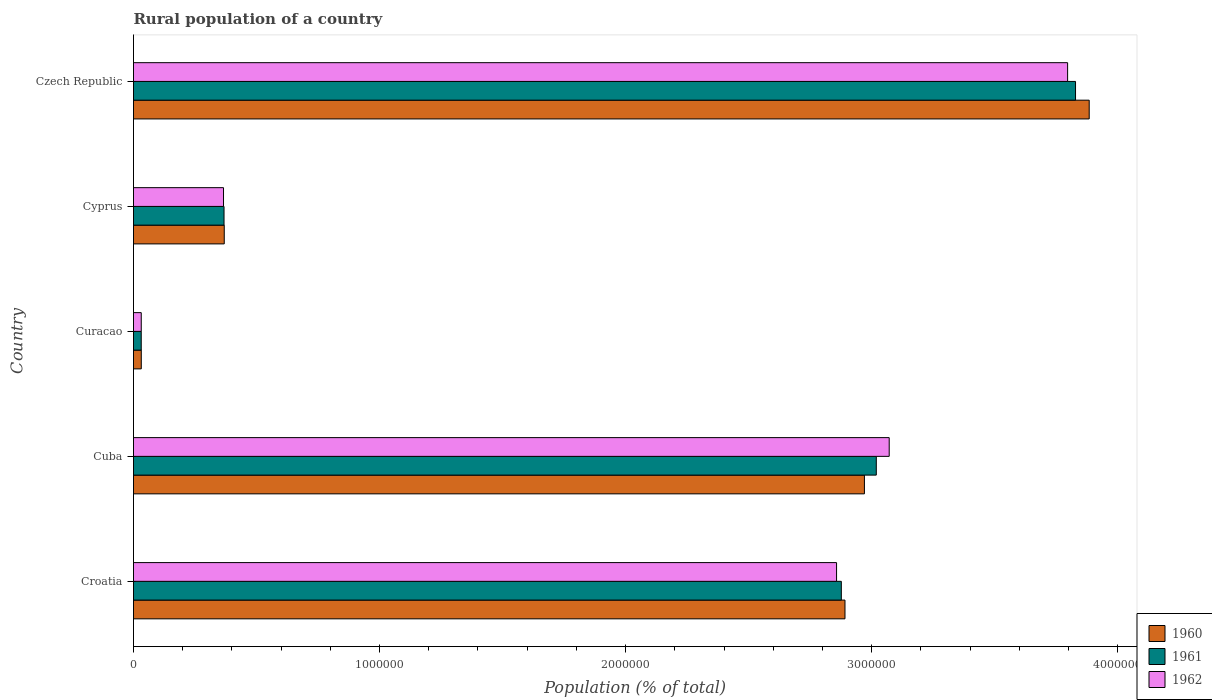How many different coloured bars are there?
Offer a terse response. 3. How many groups of bars are there?
Offer a terse response. 5. How many bars are there on the 3rd tick from the bottom?
Your response must be concise. 3. What is the label of the 1st group of bars from the top?
Give a very brief answer. Czech Republic. In how many cases, is the number of bars for a given country not equal to the number of legend labels?
Provide a succinct answer. 0. What is the rural population in 1962 in Czech Republic?
Your answer should be very brief. 3.80e+06. Across all countries, what is the maximum rural population in 1961?
Your answer should be very brief. 3.83e+06. Across all countries, what is the minimum rural population in 1960?
Your answer should be compact. 3.16e+04. In which country was the rural population in 1960 maximum?
Offer a terse response. Czech Republic. In which country was the rural population in 1962 minimum?
Offer a very short reply. Curacao. What is the total rural population in 1961 in the graph?
Your response must be concise. 1.01e+07. What is the difference between the rural population in 1962 in Cuba and that in Cyprus?
Your answer should be compact. 2.71e+06. What is the difference between the rural population in 1960 in Croatia and the rural population in 1961 in Cyprus?
Provide a short and direct response. 2.52e+06. What is the average rural population in 1961 per country?
Give a very brief answer. 2.02e+06. What is the difference between the rural population in 1961 and rural population in 1962 in Cyprus?
Provide a short and direct response. 2055. In how many countries, is the rural population in 1960 greater than 3200000 %?
Provide a succinct answer. 1. What is the ratio of the rural population in 1962 in Cuba to that in Curacao?
Keep it short and to the point. 97.58. Is the rural population in 1960 in Curacao less than that in Cyprus?
Your answer should be very brief. Yes. What is the difference between the highest and the second highest rural population in 1962?
Offer a very short reply. 7.25e+05. What is the difference between the highest and the lowest rural population in 1962?
Your answer should be very brief. 3.76e+06. In how many countries, is the rural population in 1962 greater than the average rural population in 1962 taken over all countries?
Your answer should be compact. 3. What does the 1st bar from the top in Cyprus represents?
Your answer should be compact. 1962. Is it the case that in every country, the sum of the rural population in 1962 and rural population in 1961 is greater than the rural population in 1960?
Your answer should be compact. Yes. How many bars are there?
Offer a very short reply. 15. Are all the bars in the graph horizontal?
Offer a terse response. Yes. How many countries are there in the graph?
Ensure brevity in your answer.  5. Does the graph contain grids?
Offer a very short reply. No. Where does the legend appear in the graph?
Keep it short and to the point. Bottom right. How many legend labels are there?
Your answer should be compact. 3. What is the title of the graph?
Ensure brevity in your answer.  Rural population of a country. Does "1969" appear as one of the legend labels in the graph?
Ensure brevity in your answer.  No. What is the label or title of the X-axis?
Your answer should be compact. Population (% of total). What is the label or title of the Y-axis?
Offer a very short reply. Country. What is the Population (% of total) of 1960 in Croatia?
Your response must be concise. 2.89e+06. What is the Population (% of total) of 1961 in Croatia?
Ensure brevity in your answer.  2.88e+06. What is the Population (% of total) of 1962 in Croatia?
Your answer should be compact. 2.86e+06. What is the Population (% of total) of 1960 in Cuba?
Offer a terse response. 2.97e+06. What is the Population (% of total) of 1961 in Cuba?
Give a very brief answer. 3.02e+06. What is the Population (% of total) in 1962 in Cuba?
Ensure brevity in your answer.  3.07e+06. What is the Population (% of total) in 1960 in Curacao?
Your answer should be very brief. 3.16e+04. What is the Population (% of total) in 1961 in Curacao?
Offer a very short reply. 3.14e+04. What is the Population (% of total) of 1962 in Curacao?
Provide a succinct answer. 3.15e+04. What is the Population (% of total) in 1960 in Cyprus?
Provide a succinct answer. 3.69e+05. What is the Population (% of total) of 1961 in Cyprus?
Provide a short and direct response. 3.68e+05. What is the Population (% of total) of 1962 in Cyprus?
Your answer should be very brief. 3.66e+05. What is the Population (% of total) of 1960 in Czech Republic?
Keep it short and to the point. 3.88e+06. What is the Population (% of total) of 1961 in Czech Republic?
Ensure brevity in your answer.  3.83e+06. What is the Population (% of total) in 1962 in Czech Republic?
Your answer should be compact. 3.80e+06. Across all countries, what is the maximum Population (% of total) of 1960?
Offer a very short reply. 3.88e+06. Across all countries, what is the maximum Population (% of total) of 1961?
Ensure brevity in your answer.  3.83e+06. Across all countries, what is the maximum Population (% of total) of 1962?
Provide a succinct answer. 3.80e+06. Across all countries, what is the minimum Population (% of total) of 1960?
Make the answer very short. 3.16e+04. Across all countries, what is the minimum Population (% of total) of 1961?
Provide a short and direct response. 3.14e+04. Across all countries, what is the minimum Population (% of total) in 1962?
Ensure brevity in your answer.  3.15e+04. What is the total Population (% of total) in 1960 in the graph?
Provide a short and direct response. 1.01e+07. What is the total Population (% of total) of 1961 in the graph?
Provide a succinct answer. 1.01e+07. What is the total Population (% of total) of 1962 in the graph?
Offer a terse response. 1.01e+07. What is the difference between the Population (% of total) of 1960 in Croatia and that in Cuba?
Offer a very short reply. -7.90e+04. What is the difference between the Population (% of total) of 1961 in Croatia and that in Cuba?
Offer a terse response. -1.42e+05. What is the difference between the Population (% of total) of 1962 in Croatia and that in Cuba?
Provide a succinct answer. -2.14e+05. What is the difference between the Population (% of total) of 1960 in Croatia and that in Curacao?
Your response must be concise. 2.86e+06. What is the difference between the Population (% of total) in 1961 in Croatia and that in Curacao?
Provide a short and direct response. 2.85e+06. What is the difference between the Population (% of total) of 1962 in Croatia and that in Curacao?
Give a very brief answer. 2.83e+06. What is the difference between the Population (% of total) in 1960 in Croatia and that in Cyprus?
Offer a very short reply. 2.52e+06. What is the difference between the Population (% of total) of 1961 in Croatia and that in Cyprus?
Give a very brief answer. 2.51e+06. What is the difference between the Population (% of total) in 1962 in Croatia and that in Cyprus?
Offer a very short reply. 2.49e+06. What is the difference between the Population (% of total) of 1960 in Croatia and that in Czech Republic?
Offer a terse response. -9.93e+05. What is the difference between the Population (% of total) in 1961 in Croatia and that in Czech Republic?
Your answer should be very brief. -9.52e+05. What is the difference between the Population (% of total) of 1962 in Croatia and that in Czech Republic?
Keep it short and to the point. -9.39e+05. What is the difference between the Population (% of total) in 1960 in Cuba and that in Curacao?
Your answer should be very brief. 2.94e+06. What is the difference between the Population (% of total) of 1961 in Cuba and that in Curacao?
Offer a very short reply. 2.99e+06. What is the difference between the Population (% of total) of 1962 in Cuba and that in Curacao?
Your answer should be compact. 3.04e+06. What is the difference between the Population (% of total) of 1960 in Cuba and that in Cyprus?
Give a very brief answer. 2.60e+06. What is the difference between the Population (% of total) of 1961 in Cuba and that in Cyprus?
Ensure brevity in your answer.  2.65e+06. What is the difference between the Population (% of total) of 1962 in Cuba and that in Cyprus?
Your response must be concise. 2.71e+06. What is the difference between the Population (% of total) in 1960 in Cuba and that in Czech Republic?
Give a very brief answer. -9.14e+05. What is the difference between the Population (% of total) of 1961 in Cuba and that in Czech Republic?
Your response must be concise. -8.10e+05. What is the difference between the Population (% of total) in 1962 in Cuba and that in Czech Republic?
Ensure brevity in your answer.  -7.25e+05. What is the difference between the Population (% of total) in 1960 in Curacao and that in Cyprus?
Your answer should be compact. -3.37e+05. What is the difference between the Population (% of total) of 1961 in Curacao and that in Cyprus?
Your response must be concise. -3.36e+05. What is the difference between the Population (% of total) in 1962 in Curacao and that in Cyprus?
Provide a short and direct response. -3.34e+05. What is the difference between the Population (% of total) in 1960 in Curacao and that in Czech Republic?
Provide a succinct answer. -3.85e+06. What is the difference between the Population (% of total) in 1961 in Curacao and that in Czech Republic?
Ensure brevity in your answer.  -3.80e+06. What is the difference between the Population (% of total) of 1962 in Curacao and that in Czech Republic?
Offer a very short reply. -3.76e+06. What is the difference between the Population (% of total) in 1960 in Cyprus and that in Czech Republic?
Your answer should be compact. -3.52e+06. What is the difference between the Population (% of total) of 1961 in Cyprus and that in Czech Republic?
Your response must be concise. -3.46e+06. What is the difference between the Population (% of total) in 1962 in Cyprus and that in Czech Republic?
Give a very brief answer. -3.43e+06. What is the difference between the Population (% of total) in 1960 in Croatia and the Population (% of total) in 1961 in Cuba?
Ensure brevity in your answer.  -1.27e+05. What is the difference between the Population (% of total) of 1960 in Croatia and the Population (% of total) of 1962 in Cuba?
Keep it short and to the point. -1.80e+05. What is the difference between the Population (% of total) of 1961 in Croatia and the Population (% of total) of 1962 in Cuba?
Make the answer very short. -1.95e+05. What is the difference between the Population (% of total) in 1960 in Croatia and the Population (% of total) in 1961 in Curacao?
Provide a short and direct response. 2.86e+06. What is the difference between the Population (% of total) in 1960 in Croatia and the Population (% of total) in 1962 in Curacao?
Make the answer very short. 2.86e+06. What is the difference between the Population (% of total) in 1961 in Croatia and the Population (% of total) in 1962 in Curacao?
Offer a very short reply. 2.85e+06. What is the difference between the Population (% of total) of 1960 in Croatia and the Population (% of total) of 1961 in Cyprus?
Provide a succinct answer. 2.52e+06. What is the difference between the Population (% of total) in 1960 in Croatia and the Population (% of total) in 1962 in Cyprus?
Offer a terse response. 2.53e+06. What is the difference between the Population (% of total) in 1961 in Croatia and the Population (% of total) in 1962 in Cyprus?
Give a very brief answer. 2.51e+06. What is the difference between the Population (% of total) in 1960 in Croatia and the Population (% of total) in 1961 in Czech Republic?
Ensure brevity in your answer.  -9.37e+05. What is the difference between the Population (% of total) of 1960 in Croatia and the Population (% of total) of 1962 in Czech Republic?
Keep it short and to the point. -9.05e+05. What is the difference between the Population (% of total) in 1961 in Croatia and the Population (% of total) in 1962 in Czech Republic?
Keep it short and to the point. -9.20e+05. What is the difference between the Population (% of total) in 1960 in Cuba and the Population (% of total) in 1961 in Curacao?
Provide a succinct answer. 2.94e+06. What is the difference between the Population (% of total) in 1960 in Cuba and the Population (% of total) in 1962 in Curacao?
Keep it short and to the point. 2.94e+06. What is the difference between the Population (% of total) in 1961 in Cuba and the Population (% of total) in 1962 in Curacao?
Make the answer very short. 2.99e+06. What is the difference between the Population (% of total) in 1960 in Cuba and the Population (% of total) in 1961 in Cyprus?
Ensure brevity in your answer.  2.60e+06. What is the difference between the Population (% of total) in 1960 in Cuba and the Population (% of total) in 1962 in Cyprus?
Provide a short and direct response. 2.60e+06. What is the difference between the Population (% of total) in 1961 in Cuba and the Population (% of total) in 1962 in Cyprus?
Offer a terse response. 2.65e+06. What is the difference between the Population (% of total) in 1960 in Cuba and the Population (% of total) in 1961 in Czech Republic?
Provide a succinct answer. -8.58e+05. What is the difference between the Population (% of total) in 1960 in Cuba and the Population (% of total) in 1962 in Czech Republic?
Your answer should be compact. -8.26e+05. What is the difference between the Population (% of total) of 1961 in Cuba and the Population (% of total) of 1962 in Czech Republic?
Ensure brevity in your answer.  -7.78e+05. What is the difference between the Population (% of total) of 1960 in Curacao and the Population (% of total) of 1961 in Cyprus?
Ensure brevity in your answer.  -3.36e+05. What is the difference between the Population (% of total) in 1960 in Curacao and the Population (% of total) in 1962 in Cyprus?
Provide a short and direct response. -3.34e+05. What is the difference between the Population (% of total) in 1961 in Curacao and the Population (% of total) in 1962 in Cyprus?
Make the answer very short. -3.34e+05. What is the difference between the Population (% of total) in 1960 in Curacao and the Population (% of total) in 1961 in Czech Republic?
Ensure brevity in your answer.  -3.80e+06. What is the difference between the Population (% of total) of 1960 in Curacao and the Population (% of total) of 1962 in Czech Republic?
Provide a succinct answer. -3.76e+06. What is the difference between the Population (% of total) of 1961 in Curacao and the Population (% of total) of 1962 in Czech Republic?
Offer a very short reply. -3.77e+06. What is the difference between the Population (% of total) in 1960 in Cyprus and the Population (% of total) in 1961 in Czech Republic?
Provide a succinct answer. -3.46e+06. What is the difference between the Population (% of total) of 1960 in Cyprus and the Population (% of total) of 1962 in Czech Republic?
Give a very brief answer. -3.43e+06. What is the difference between the Population (% of total) of 1961 in Cyprus and the Population (% of total) of 1962 in Czech Republic?
Provide a succinct answer. -3.43e+06. What is the average Population (% of total) in 1960 per country?
Provide a succinct answer. 2.03e+06. What is the average Population (% of total) of 1961 per country?
Provide a short and direct response. 2.02e+06. What is the average Population (% of total) of 1962 per country?
Ensure brevity in your answer.  2.02e+06. What is the difference between the Population (% of total) of 1960 and Population (% of total) of 1961 in Croatia?
Give a very brief answer. 1.48e+04. What is the difference between the Population (% of total) of 1960 and Population (% of total) of 1962 in Croatia?
Offer a terse response. 3.42e+04. What is the difference between the Population (% of total) of 1961 and Population (% of total) of 1962 in Croatia?
Keep it short and to the point. 1.94e+04. What is the difference between the Population (% of total) of 1960 and Population (% of total) of 1961 in Cuba?
Offer a very short reply. -4.82e+04. What is the difference between the Population (% of total) in 1960 and Population (% of total) in 1962 in Cuba?
Keep it short and to the point. -1.01e+05. What is the difference between the Population (% of total) in 1961 and Population (% of total) in 1962 in Cuba?
Your answer should be compact. -5.25e+04. What is the difference between the Population (% of total) of 1960 and Population (% of total) of 1961 in Curacao?
Your response must be concise. 165. What is the difference between the Population (% of total) in 1960 and Population (% of total) in 1962 in Curacao?
Your answer should be compact. 94. What is the difference between the Population (% of total) of 1961 and Population (% of total) of 1962 in Curacao?
Ensure brevity in your answer.  -71. What is the difference between the Population (% of total) in 1960 and Population (% of total) in 1961 in Cyprus?
Your response must be concise. 922. What is the difference between the Population (% of total) of 1960 and Population (% of total) of 1962 in Cyprus?
Give a very brief answer. 2977. What is the difference between the Population (% of total) in 1961 and Population (% of total) in 1962 in Cyprus?
Make the answer very short. 2055. What is the difference between the Population (% of total) in 1960 and Population (% of total) in 1961 in Czech Republic?
Offer a terse response. 5.56e+04. What is the difference between the Population (% of total) of 1960 and Population (% of total) of 1962 in Czech Republic?
Offer a very short reply. 8.78e+04. What is the difference between the Population (% of total) of 1961 and Population (% of total) of 1962 in Czech Republic?
Your answer should be compact. 3.22e+04. What is the ratio of the Population (% of total) of 1960 in Croatia to that in Cuba?
Your answer should be compact. 0.97. What is the ratio of the Population (% of total) of 1961 in Croatia to that in Cuba?
Give a very brief answer. 0.95. What is the ratio of the Population (% of total) in 1962 in Croatia to that in Cuba?
Offer a terse response. 0.93. What is the ratio of the Population (% of total) in 1960 in Croatia to that in Curacao?
Ensure brevity in your answer.  91.6. What is the ratio of the Population (% of total) in 1961 in Croatia to that in Curacao?
Ensure brevity in your answer.  91.61. What is the ratio of the Population (% of total) in 1962 in Croatia to that in Curacao?
Your answer should be very brief. 90.79. What is the ratio of the Population (% of total) in 1960 in Croatia to that in Cyprus?
Your response must be concise. 7.84. What is the ratio of the Population (% of total) in 1961 in Croatia to that in Cyprus?
Give a very brief answer. 7.82. What is the ratio of the Population (% of total) in 1962 in Croatia to that in Cyprus?
Ensure brevity in your answer.  7.81. What is the ratio of the Population (% of total) in 1960 in Croatia to that in Czech Republic?
Offer a very short reply. 0.74. What is the ratio of the Population (% of total) of 1961 in Croatia to that in Czech Republic?
Your answer should be compact. 0.75. What is the ratio of the Population (% of total) in 1962 in Croatia to that in Czech Republic?
Ensure brevity in your answer.  0.75. What is the ratio of the Population (% of total) in 1960 in Cuba to that in Curacao?
Make the answer very short. 94.1. What is the ratio of the Population (% of total) of 1961 in Cuba to that in Curacao?
Provide a short and direct response. 96.13. What is the ratio of the Population (% of total) of 1962 in Cuba to that in Curacao?
Make the answer very short. 97.58. What is the ratio of the Population (% of total) in 1960 in Cuba to that in Cyprus?
Provide a succinct answer. 8.05. What is the ratio of the Population (% of total) of 1961 in Cuba to that in Cyprus?
Keep it short and to the point. 8.21. What is the ratio of the Population (% of total) in 1962 in Cuba to that in Cyprus?
Offer a very short reply. 8.4. What is the ratio of the Population (% of total) in 1960 in Cuba to that in Czech Republic?
Offer a very short reply. 0.76. What is the ratio of the Population (% of total) of 1961 in Cuba to that in Czech Republic?
Provide a short and direct response. 0.79. What is the ratio of the Population (% of total) of 1962 in Cuba to that in Czech Republic?
Make the answer very short. 0.81. What is the ratio of the Population (% of total) of 1960 in Curacao to that in Cyprus?
Keep it short and to the point. 0.09. What is the ratio of the Population (% of total) in 1961 in Curacao to that in Cyprus?
Ensure brevity in your answer.  0.09. What is the ratio of the Population (% of total) of 1962 in Curacao to that in Cyprus?
Ensure brevity in your answer.  0.09. What is the ratio of the Population (% of total) in 1960 in Curacao to that in Czech Republic?
Offer a very short reply. 0.01. What is the ratio of the Population (% of total) in 1961 in Curacao to that in Czech Republic?
Make the answer very short. 0.01. What is the ratio of the Population (% of total) in 1962 in Curacao to that in Czech Republic?
Keep it short and to the point. 0.01. What is the ratio of the Population (% of total) in 1960 in Cyprus to that in Czech Republic?
Your response must be concise. 0.1. What is the ratio of the Population (% of total) in 1961 in Cyprus to that in Czech Republic?
Your answer should be compact. 0.1. What is the ratio of the Population (% of total) in 1962 in Cyprus to that in Czech Republic?
Offer a terse response. 0.1. What is the difference between the highest and the second highest Population (% of total) in 1960?
Keep it short and to the point. 9.14e+05. What is the difference between the highest and the second highest Population (% of total) of 1961?
Keep it short and to the point. 8.10e+05. What is the difference between the highest and the second highest Population (% of total) of 1962?
Provide a succinct answer. 7.25e+05. What is the difference between the highest and the lowest Population (% of total) in 1960?
Offer a very short reply. 3.85e+06. What is the difference between the highest and the lowest Population (% of total) in 1961?
Give a very brief answer. 3.80e+06. What is the difference between the highest and the lowest Population (% of total) in 1962?
Give a very brief answer. 3.76e+06. 